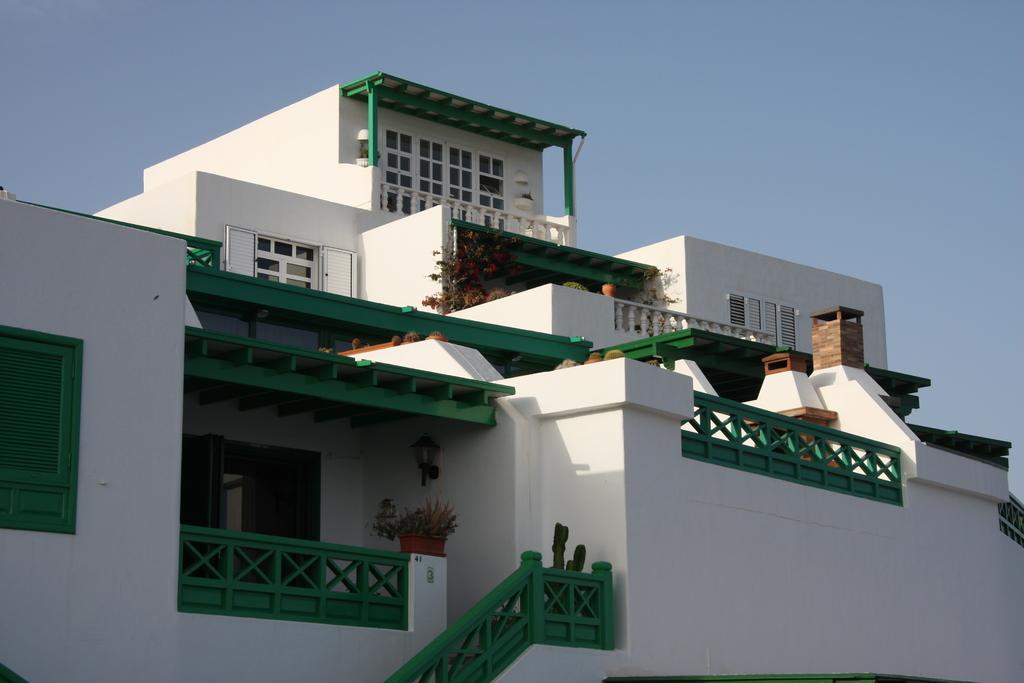Please provide a concise description of this image. In this image we can see the front view of a building. 